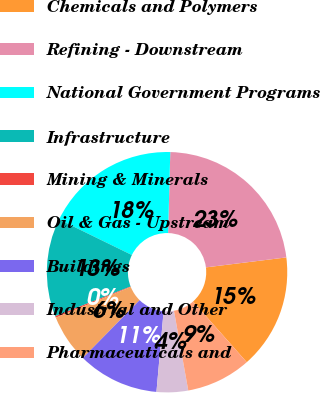Convert chart to OTSL. <chart><loc_0><loc_0><loc_500><loc_500><pie_chart><fcel>Chemicals and Polymers<fcel>Refining - Downstream<fcel>National Government Programs<fcel>Infrastructure<fcel>Mining & Minerals<fcel>Oil & Gas - Upstream<fcel>Buildings<fcel>Industrial and Other<fcel>Pharmaceuticals and<nl><fcel>15.43%<fcel>22.61%<fcel>18.2%<fcel>13.19%<fcel>0.21%<fcel>6.47%<fcel>10.95%<fcel>4.23%<fcel>8.71%<nl></chart> 